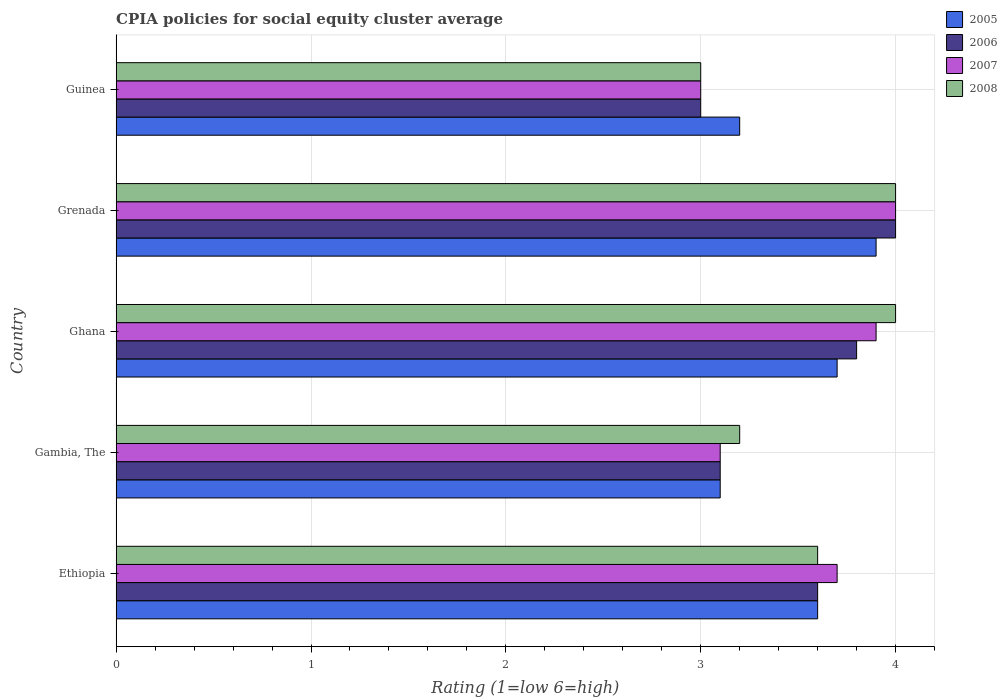How many different coloured bars are there?
Provide a short and direct response. 4. How many bars are there on the 2nd tick from the top?
Keep it short and to the point. 4. How many bars are there on the 4th tick from the bottom?
Your answer should be very brief. 4. What is the label of the 5th group of bars from the top?
Provide a short and direct response. Ethiopia. What is the CPIA rating in 2005 in Grenada?
Make the answer very short. 3.9. In which country was the CPIA rating in 2008 maximum?
Offer a very short reply. Ghana. In which country was the CPIA rating in 2007 minimum?
Provide a succinct answer. Guinea. What is the difference between the CPIA rating in 2005 in Ethiopia and that in Guinea?
Keep it short and to the point. 0.4. What is the difference between the CPIA rating in 2007 in Ghana and the CPIA rating in 2005 in Grenada?
Keep it short and to the point. 0. What is the average CPIA rating in 2008 per country?
Provide a short and direct response. 3.56. What is the difference between the CPIA rating in 2007 and CPIA rating in 2006 in Ethiopia?
Your response must be concise. 0.1. In how many countries, is the CPIA rating in 2005 greater than 3.8 ?
Your answer should be very brief. 1. What is the ratio of the CPIA rating in 2008 in Grenada to that in Guinea?
Your response must be concise. 1.33. Is the CPIA rating in 2008 in Gambia, The less than that in Grenada?
Your response must be concise. Yes. Is the difference between the CPIA rating in 2007 in Gambia, The and Ghana greater than the difference between the CPIA rating in 2006 in Gambia, The and Ghana?
Make the answer very short. No. What is the difference between the highest and the second highest CPIA rating in 2008?
Your answer should be compact. 0. What is the difference between the highest and the lowest CPIA rating in 2005?
Give a very brief answer. 0.8. Is it the case that in every country, the sum of the CPIA rating in 2005 and CPIA rating in 2008 is greater than the sum of CPIA rating in 2006 and CPIA rating in 2007?
Offer a terse response. No. What does the 1st bar from the top in Ghana represents?
Give a very brief answer. 2008. What does the 3rd bar from the bottom in Grenada represents?
Offer a very short reply. 2007. Is it the case that in every country, the sum of the CPIA rating in 2005 and CPIA rating in 2008 is greater than the CPIA rating in 2006?
Provide a short and direct response. Yes. How many bars are there?
Provide a short and direct response. 20. Are all the bars in the graph horizontal?
Keep it short and to the point. Yes. What is the difference between two consecutive major ticks on the X-axis?
Your response must be concise. 1. Does the graph contain any zero values?
Give a very brief answer. No. Where does the legend appear in the graph?
Keep it short and to the point. Top right. How are the legend labels stacked?
Your answer should be compact. Vertical. What is the title of the graph?
Give a very brief answer. CPIA policies for social equity cluster average. Does "1974" appear as one of the legend labels in the graph?
Your response must be concise. No. What is the label or title of the X-axis?
Give a very brief answer. Rating (1=low 6=high). What is the label or title of the Y-axis?
Your answer should be compact. Country. What is the Rating (1=low 6=high) of 2005 in Ethiopia?
Give a very brief answer. 3.6. What is the Rating (1=low 6=high) of 2006 in Ethiopia?
Provide a succinct answer. 3.6. What is the Rating (1=low 6=high) in 2007 in Ethiopia?
Offer a terse response. 3.7. What is the Rating (1=low 6=high) in 2008 in Ethiopia?
Your answer should be compact. 3.6. What is the Rating (1=low 6=high) of 2005 in Gambia, The?
Provide a short and direct response. 3.1. What is the Rating (1=low 6=high) in 2008 in Gambia, The?
Give a very brief answer. 3.2. What is the Rating (1=low 6=high) in 2006 in Ghana?
Your answer should be very brief. 3.8. What is the Rating (1=low 6=high) in 2008 in Ghana?
Offer a very short reply. 4. What is the Rating (1=low 6=high) in 2006 in Grenada?
Make the answer very short. 4. What is the Rating (1=low 6=high) of 2007 in Grenada?
Offer a terse response. 4. What is the Rating (1=low 6=high) in 2008 in Grenada?
Make the answer very short. 4. What is the Rating (1=low 6=high) in 2005 in Guinea?
Provide a short and direct response. 3.2. What is the Rating (1=low 6=high) in 2006 in Guinea?
Offer a terse response. 3. Across all countries, what is the maximum Rating (1=low 6=high) in 2005?
Provide a short and direct response. 3.9. Across all countries, what is the maximum Rating (1=low 6=high) in 2006?
Offer a very short reply. 4. Across all countries, what is the minimum Rating (1=low 6=high) of 2007?
Your response must be concise. 3. Across all countries, what is the minimum Rating (1=low 6=high) in 2008?
Give a very brief answer. 3. What is the total Rating (1=low 6=high) in 2007 in the graph?
Give a very brief answer. 17.7. What is the difference between the Rating (1=low 6=high) of 2005 in Ethiopia and that in Gambia, The?
Make the answer very short. 0.5. What is the difference between the Rating (1=low 6=high) of 2006 in Ethiopia and that in Gambia, The?
Keep it short and to the point. 0.5. What is the difference between the Rating (1=low 6=high) of 2007 in Ethiopia and that in Gambia, The?
Ensure brevity in your answer.  0.6. What is the difference between the Rating (1=low 6=high) in 2005 in Ethiopia and that in Ghana?
Offer a terse response. -0.1. What is the difference between the Rating (1=low 6=high) in 2007 in Ethiopia and that in Ghana?
Your answer should be very brief. -0.2. What is the difference between the Rating (1=low 6=high) in 2008 in Ethiopia and that in Ghana?
Your answer should be very brief. -0.4. What is the difference between the Rating (1=low 6=high) in 2006 in Ethiopia and that in Grenada?
Offer a very short reply. -0.4. What is the difference between the Rating (1=low 6=high) in 2007 in Ethiopia and that in Grenada?
Your answer should be compact. -0.3. What is the difference between the Rating (1=low 6=high) of 2008 in Ethiopia and that in Grenada?
Your response must be concise. -0.4. What is the difference between the Rating (1=low 6=high) in 2005 in Ethiopia and that in Guinea?
Offer a very short reply. 0.4. What is the difference between the Rating (1=low 6=high) of 2007 in Ethiopia and that in Guinea?
Offer a very short reply. 0.7. What is the difference between the Rating (1=low 6=high) in 2008 in Ethiopia and that in Guinea?
Offer a terse response. 0.6. What is the difference between the Rating (1=low 6=high) in 2007 in Gambia, The and that in Ghana?
Your response must be concise. -0.8. What is the difference between the Rating (1=low 6=high) of 2008 in Gambia, The and that in Ghana?
Give a very brief answer. -0.8. What is the difference between the Rating (1=low 6=high) in 2005 in Gambia, The and that in Grenada?
Provide a succinct answer. -0.8. What is the difference between the Rating (1=low 6=high) in 2007 in Gambia, The and that in Grenada?
Your response must be concise. -0.9. What is the difference between the Rating (1=low 6=high) in 2006 in Gambia, The and that in Guinea?
Ensure brevity in your answer.  0.1. What is the difference between the Rating (1=low 6=high) of 2008 in Gambia, The and that in Guinea?
Offer a very short reply. 0.2. What is the difference between the Rating (1=low 6=high) in 2007 in Ghana and that in Grenada?
Ensure brevity in your answer.  -0.1. What is the difference between the Rating (1=low 6=high) in 2008 in Ghana and that in Grenada?
Offer a terse response. 0. What is the difference between the Rating (1=low 6=high) of 2005 in Ghana and that in Guinea?
Your response must be concise. 0.5. What is the difference between the Rating (1=low 6=high) in 2007 in Ghana and that in Guinea?
Your answer should be very brief. 0.9. What is the difference between the Rating (1=low 6=high) of 2008 in Ghana and that in Guinea?
Provide a succinct answer. 1. What is the difference between the Rating (1=low 6=high) in 2005 in Grenada and that in Guinea?
Provide a succinct answer. 0.7. What is the difference between the Rating (1=low 6=high) of 2006 in Grenada and that in Guinea?
Keep it short and to the point. 1. What is the difference between the Rating (1=low 6=high) of 2007 in Grenada and that in Guinea?
Make the answer very short. 1. What is the difference between the Rating (1=low 6=high) in 2005 in Ethiopia and the Rating (1=low 6=high) in 2007 in Gambia, The?
Provide a short and direct response. 0.5. What is the difference between the Rating (1=low 6=high) in 2006 in Ethiopia and the Rating (1=low 6=high) in 2007 in Gambia, The?
Offer a terse response. 0.5. What is the difference between the Rating (1=low 6=high) of 2005 in Ethiopia and the Rating (1=low 6=high) of 2006 in Ghana?
Your response must be concise. -0.2. What is the difference between the Rating (1=low 6=high) of 2005 in Ethiopia and the Rating (1=low 6=high) of 2007 in Ghana?
Offer a terse response. -0.3. What is the difference between the Rating (1=low 6=high) in 2005 in Ethiopia and the Rating (1=low 6=high) in 2006 in Grenada?
Your answer should be compact. -0.4. What is the difference between the Rating (1=low 6=high) of 2005 in Ethiopia and the Rating (1=low 6=high) of 2007 in Grenada?
Your answer should be compact. -0.4. What is the difference between the Rating (1=low 6=high) in 2005 in Ethiopia and the Rating (1=low 6=high) in 2006 in Guinea?
Your answer should be compact. 0.6. What is the difference between the Rating (1=low 6=high) of 2006 in Ethiopia and the Rating (1=low 6=high) of 2008 in Guinea?
Your response must be concise. 0.6. What is the difference between the Rating (1=low 6=high) in 2007 in Ethiopia and the Rating (1=low 6=high) in 2008 in Guinea?
Make the answer very short. 0.7. What is the difference between the Rating (1=low 6=high) of 2005 in Gambia, The and the Rating (1=low 6=high) of 2006 in Ghana?
Ensure brevity in your answer.  -0.7. What is the difference between the Rating (1=low 6=high) of 2005 in Gambia, The and the Rating (1=low 6=high) of 2007 in Ghana?
Ensure brevity in your answer.  -0.8. What is the difference between the Rating (1=low 6=high) in 2007 in Gambia, The and the Rating (1=low 6=high) in 2008 in Ghana?
Your answer should be very brief. -0.9. What is the difference between the Rating (1=low 6=high) of 2005 in Gambia, The and the Rating (1=low 6=high) of 2007 in Grenada?
Your answer should be very brief. -0.9. What is the difference between the Rating (1=low 6=high) in 2006 in Gambia, The and the Rating (1=low 6=high) in 2007 in Grenada?
Your response must be concise. -0.9. What is the difference between the Rating (1=low 6=high) in 2006 in Gambia, The and the Rating (1=low 6=high) in 2008 in Grenada?
Ensure brevity in your answer.  -0.9. What is the difference between the Rating (1=low 6=high) of 2007 in Gambia, The and the Rating (1=low 6=high) of 2008 in Grenada?
Your response must be concise. -0.9. What is the difference between the Rating (1=low 6=high) in 2005 in Gambia, The and the Rating (1=low 6=high) in 2008 in Guinea?
Your answer should be compact. 0.1. What is the difference between the Rating (1=low 6=high) in 2006 in Gambia, The and the Rating (1=low 6=high) in 2008 in Guinea?
Your answer should be very brief. 0.1. What is the difference between the Rating (1=low 6=high) in 2005 in Ghana and the Rating (1=low 6=high) in 2006 in Grenada?
Give a very brief answer. -0.3. What is the difference between the Rating (1=low 6=high) of 2005 in Ghana and the Rating (1=low 6=high) of 2007 in Grenada?
Offer a terse response. -0.3. What is the difference between the Rating (1=low 6=high) of 2005 in Ghana and the Rating (1=low 6=high) of 2008 in Grenada?
Your response must be concise. -0.3. What is the difference between the Rating (1=low 6=high) of 2006 in Ghana and the Rating (1=low 6=high) of 2007 in Grenada?
Your answer should be very brief. -0.2. What is the difference between the Rating (1=low 6=high) in 2006 in Ghana and the Rating (1=low 6=high) in 2008 in Grenada?
Make the answer very short. -0.2. What is the difference between the Rating (1=low 6=high) of 2007 in Ghana and the Rating (1=low 6=high) of 2008 in Grenada?
Keep it short and to the point. -0.1. What is the difference between the Rating (1=low 6=high) in 2005 in Ghana and the Rating (1=low 6=high) in 2006 in Guinea?
Keep it short and to the point. 0.7. What is the difference between the Rating (1=low 6=high) in 2005 in Grenada and the Rating (1=low 6=high) in 2008 in Guinea?
Make the answer very short. 0.9. What is the difference between the Rating (1=low 6=high) in 2006 in Grenada and the Rating (1=low 6=high) in 2007 in Guinea?
Your answer should be compact. 1. What is the difference between the Rating (1=low 6=high) in 2006 in Grenada and the Rating (1=low 6=high) in 2008 in Guinea?
Your answer should be very brief. 1. What is the difference between the Rating (1=low 6=high) of 2007 in Grenada and the Rating (1=low 6=high) of 2008 in Guinea?
Ensure brevity in your answer.  1. What is the average Rating (1=low 6=high) in 2007 per country?
Provide a succinct answer. 3.54. What is the average Rating (1=low 6=high) of 2008 per country?
Provide a succinct answer. 3.56. What is the difference between the Rating (1=low 6=high) of 2006 and Rating (1=low 6=high) of 2007 in Ethiopia?
Your answer should be very brief. -0.1. What is the difference between the Rating (1=low 6=high) of 2006 and Rating (1=low 6=high) of 2008 in Ethiopia?
Give a very brief answer. 0. What is the difference between the Rating (1=low 6=high) in 2007 and Rating (1=low 6=high) in 2008 in Ethiopia?
Provide a succinct answer. 0.1. What is the difference between the Rating (1=low 6=high) in 2005 and Rating (1=low 6=high) in 2006 in Gambia, The?
Provide a succinct answer. 0. What is the difference between the Rating (1=low 6=high) in 2005 and Rating (1=low 6=high) in 2007 in Gambia, The?
Your answer should be very brief. 0. What is the difference between the Rating (1=low 6=high) of 2006 and Rating (1=low 6=high) of 2007 in Gambia, The?
Keep it short and to the point. 0. What is the difference between the Rating (1=low 6=high) of 2006 and Rating (1=low 6=high) of 2008 in Gambia, The?
Provide a short and direct response. -0.1. What is the difference between the Rating (1=low 6=high) of 2005 and Rating (1=low 6=high) of 2007 in Ghana?
Your response must be concise. -0.2. What is the difference between the Rating (1=low 6=high) of 2005 and Rating (1=low 6=high) of 2008 in Ghana?
Offer a terse response. -0.3. What is the difference between the Rating (1=low 6=high) in 2007 and Rating (1=low 6=high) in 2008 in Ghana?
Make the answer very short. -0.1. What is the difference between the Rating (1=low 6=high) of 2005 and Rating (1=low 6=high) of 2006 in Grenada?
Ensure brevity in your answer.  -0.1. What is the difference between the Rating (1=low 6=high) of 2005 and Rating (1=low 6=high) of 2007 in Grenada?
Provide a succinct answer. -0.1. What is the difference between the Rating (1=low 6=high) in 2005 and Rating (1=low 6=high) in 2008 in Grenada?
Give a very brief answer. -0.1. What is the difference between the Rating (1=low 6=high) in 2006 and Rating (1=low 6=high) in 2007 in Grenada?
Ensure brevity in your answer.  0. What is the difference between the Rating (1=low 6=high) in 2006 and Rating (1=low 6=high) in 2008 in Grenada?
Your response must be concise. 0. What is the difference between the Rating (1=low 6=high) of 2007 and Rating (1=low 6=high) of 2008 in Grenada?
Offer a terse response. 0. What is the difference between the Rating (1=low 6=high) of 2005 and Rating (1=low 6=high) of 2008 in Guinea?
Make the answer very short. 0.2. What is the difference between the Rating (1=low 6=high) in 2006 and Rating (1=low 6=high) in 2007 in Guinea?
Offer a terse response. 0. What is the difference between the Rating (1=low 6=high) of 2007 and Rating (1=low 6=high) of 2008 in Guinea?
Provide a succinct answer. 0. What is the ratio of the Rating (1=low 6=high) of 2005 in Ethiopia to that in Gambia, The?
Your answer should be very brief. 1.16. What is the ratio of the Rating (1=low 6=high) of 2006 in Ethiopia to that in Gambia, The?
Provide a succinct answer. 1.16. What is the ratio of the Rating (1=low 6=high) of 2007 in Ethiopia to that in Gambia, The?
Give a very brief answer. 1.19. What is the ratio of the Rating (1=low 6=high) of 2008 in Ethiopia to that in Gambia, The?
Your response must be concise. 1.12. What is the ratio of the Rating (1=low 6=high) of 2007 in Ethiopia to that in Ghana?
Make the answer very short. 0.95. What is the ratio of the Rating (1=low 6=high) of 2008 in Ethiopia to that in Ghana?
Provide a short and direct response. 0.9. What is the ratio of the Rating (1=low 6=high) of 2007 in Ethiopia to that in Grenada?
Your answer should be very brief. 0.93. What is the ratio of the Rating (1=low 6=high) in 2008 in Ethiopia to that in Grenada?
Your response must be concise. 0.9. What is the ratio of the Rating (1=low 6=high) in 2006 in Ethiopia to that in Guinea?
Offer a very short reply. 1.2. What is the ratio of the Rating (1=low 6=high) of 2007 in Ethiopia to that in Guinea?
Offer a very short reply. 1.23. What is the ratio of the Rating (1=low 6=high) of 2008 in Ethiopia to that in Guinea?
Provide a succinct answer. 1.2. What is the ratio of the Rating (1=low 6=high) of 2005 in Gambia, The to that in Ghana?
Give a very brief answer. 0.84. What is the ratio of the Rating (1=low 6=high) of 2006 in Gambia, The to that in Ghana?
Make the answer very short. 0.82. What is the ratio of the Rating (1=low 6=high) in 2007 in Gambia, The to that in Ghana?
Provide a short and direct response. 0.79. What is the ratio of the Rating (1=low 6=high) in 2008 in Gambia, The to that in Ghana?
Provide a short and direct response. 0.8. What is the ratio of the Rating (1=low 6=high) in 2005 in Gambia, The to that in Grenada?
Make the answer very short. 0.79. What is the ratio of the Rating (1=low 6=high) of 2006 in Gambia, The to that in Grenada?
Provide a succinct answer. 0.78. What is the ratio of the Rating (1=low 6=high) in 2007 in Gambia, The to that in Grenada?
Offer a terse response. 0.78. What is the ratio of the Rating (1=low 6=high) of 2005 in Gambia, The to that in Guinea?
Give a very brief answer. 0.97. What is the ratio of the Rating (1=low 6=high) in 2006 in Gambia, The to that in Guinea?
Your answer should be very brief. 1.03. What is the ratio of the Rating (1=low 6=high) of 2007 in Gambia, The to that in Guinea?
Your answer should be very brief. 1.03. What is the ratio of the Rating (1=low 6=high) of 2008 in Gambia, The to that in Guinea?
Your answer should be compact. 1.07. What is the ratio of the Rating (1=low 6=high) in 2005 in Ghana to that in Grenada?
Your response must be concise. 0.95. What is the ratio of the Rating (1=low 6=high) in 2007 in Ghana to that in Grenada?
Offer a very short reply. 0.97. What is the ratio of the Rating (1=low 6=high) in 2005 in Ghana to that in Guinea?
Provide a succinct answer. 1.16. What is the ratio of the Rating (1=low 6=high) of 2006 in Ghana to that in Guinea?
Your answer should be very brief. 1.27. What is the ratio of the Rating (1=low 6=high) of 2008 in Ghana to that in Guinea?
Give a very brief answer. 1.33. What is the ratio of the Rating (1=low 6=high) of 2005 in Grenada to that in Guinea?
Give a very brief answer. 1.22. What is the ratio of the Rating (1=low 6=high) in 2007 in Grenada to that in Guinea?
Make the answer very short. 1.33. What is the difference between the highest and the second highest Rating (1=low 6=high) of 2005?
Ensure brevity in your answer.  0.2. What is the difference between the highest and the second highest Rating (1=low 6=high) of 2007?
Offer a very short reply. 0.1. What is the difference between the highest and the second highest Rating (1=low 6=high) of 2008?
Give a very brief answer. 0. What is the difference between the highest and the lowest Rating (1=low 6=high) in 2005?
Provide a succinct answer. 0.8. What is the difference between the highest and the lowest Rating (1=low 6=high) in 2006?
Your answer should be compact. 1. What is the difference between the highest and the lowest Rating (1=low 6=high) in 2007?
Give a very brief answer. 1. What is the difference between the highest and the lowest Rating (1=low 6=high) of 2008?
Make the answer very short. 1. 